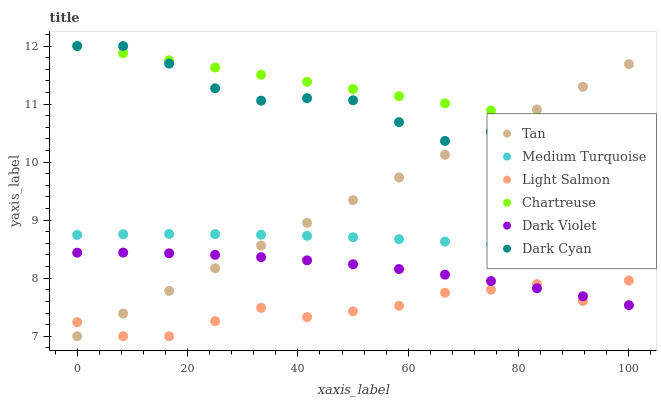Does Light Salmon have the minimum area under the curve?
Answer yes or no. Yes. Does Chartreuse have the maximum area under the curve?
Answer yes or no. Yes. Does Dark Violet have the minimum area under the curve?
Answer yes or no. No. Does Dark Violet have the maximum area under the curve?
Answer yes or no. No. Is Tan the smoothest?
Answer yes or no. Yes. Is Dark Cyan the roughest?
Answer yes or no. Yes. Is Dark Violet the smoothest?
Answer yes or no. No. Is Dark Violet the roughest?
Answer yes or no. No. Does Light Salmon have the lowest value?
Answer yes or no. Yes. Does Dark Violet have the lowest value?
Answer yes or no. No. Does Dark Cyan have the highest value?
Answer yes or no. Yes. Does Dark Violet have the highest value?
Answer yes or no. No. Is Dark Violet less than Medium Turquoise?
Answer yes or no. Yes. Is Chartreuse greater than Light Salmon?
Answer yes or no. Yes. Does Tan intersect Dark Cyan?
Answer yes or no. Yes. Is Tan less than Dark Cyan?
Answer yes or no. No. Is Tan greater than Dark Cyan?
Answer yes or no. No. Does Dark Violet intersect Medium Turquoise?
Answer yes or no. No. 